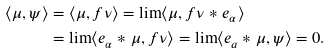<formula> <loc_0><loc_0><loc_500><loc_500>\langle \mu , \psi \rangle & = \langle \mu , f \nu \rangle = \lim \langle \mu , f \nu * e _ { \alpha } \rangle \\ & = \lim \langle e _ { \alpha } * \mu , f \nu \rangle = \lim \langle e _ { a } * \mu , \psi \rangle = 0 .</formula> 